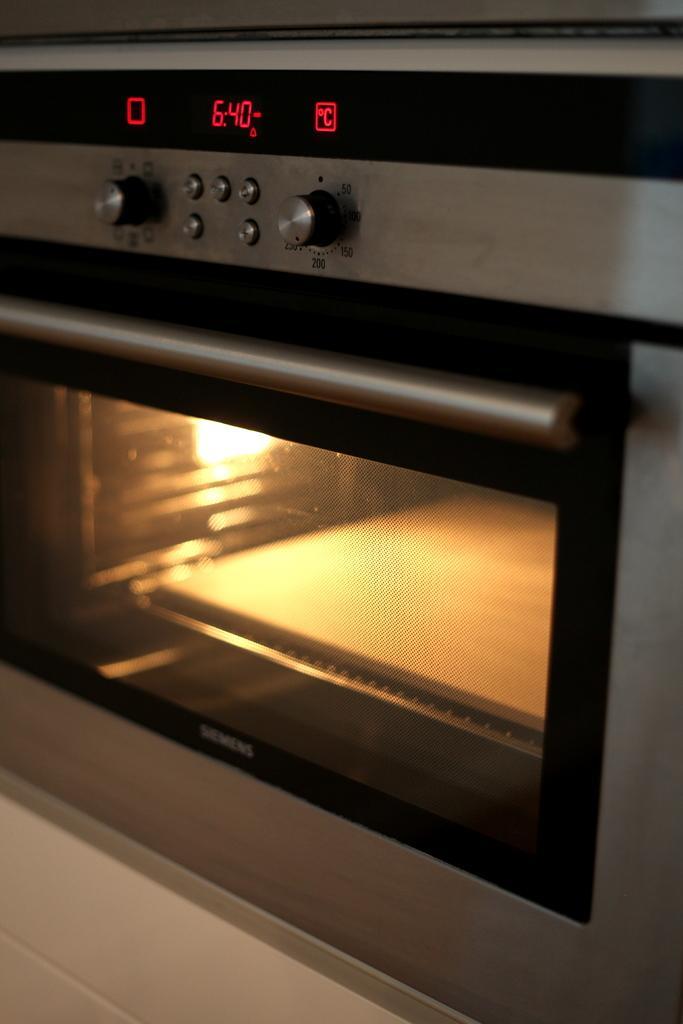How would you summarize this image in a sentence or two? In this picture we can see a microwave oven on the platform. 